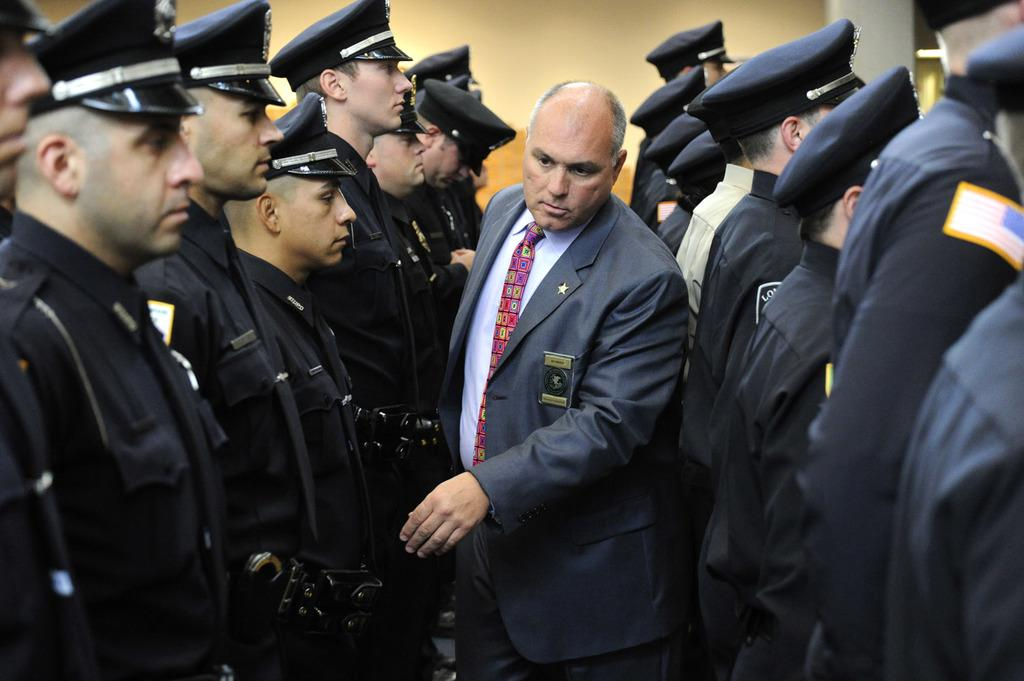How many persons are in the image? There are persons in the image. What are the persons wearing? The persons are wearing black uniforms and black caps. Can you describe the man in the image? There is a man wearing a blue suit in the image. What is visible in the background of the image? There is a wall in the background of the image. What type of cherries can be seen growing on the oven in the image? There is no oven or cherries present in the image. What is the end result of the persons' actions in the image? The image does not depict any actions or events that have a clear end result. 